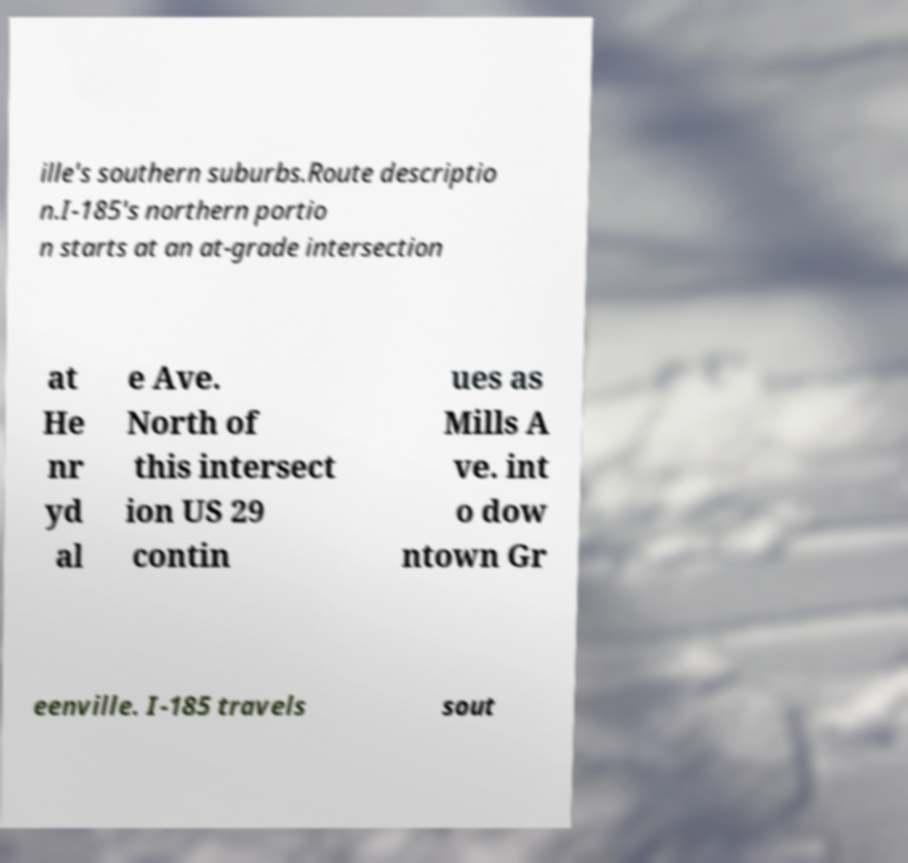What messages or text are displayed in this image? I need them in a readable, typed format. ille's southern suburbs.Route descriptio n.I-185's northern portio n starts at an at-grade intersection at He nr yd al e Ave. North of this intersect ion US 29 contin ues as Mills A ve. int o dow ntown Gr eenville. I-185 travels sout 